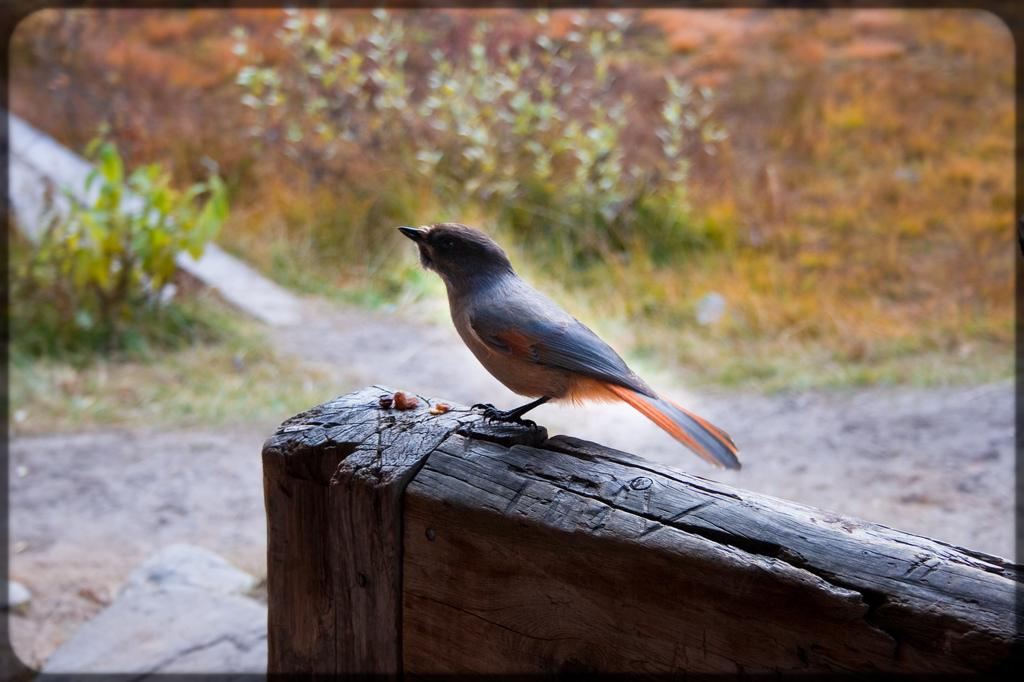What type of animal is present in the image? There is a bird in the image. Can you describe the background of the image? The background of the image is blurry. What else can be seen in the image besides the bird? There are plants visible in the image. What type of receipt is the doctor holding in the image? There is no doctor or receipt present in the image; it features a bird and plants. Can you tell me how many knives are visible in the image? There are no knives present in the image. 